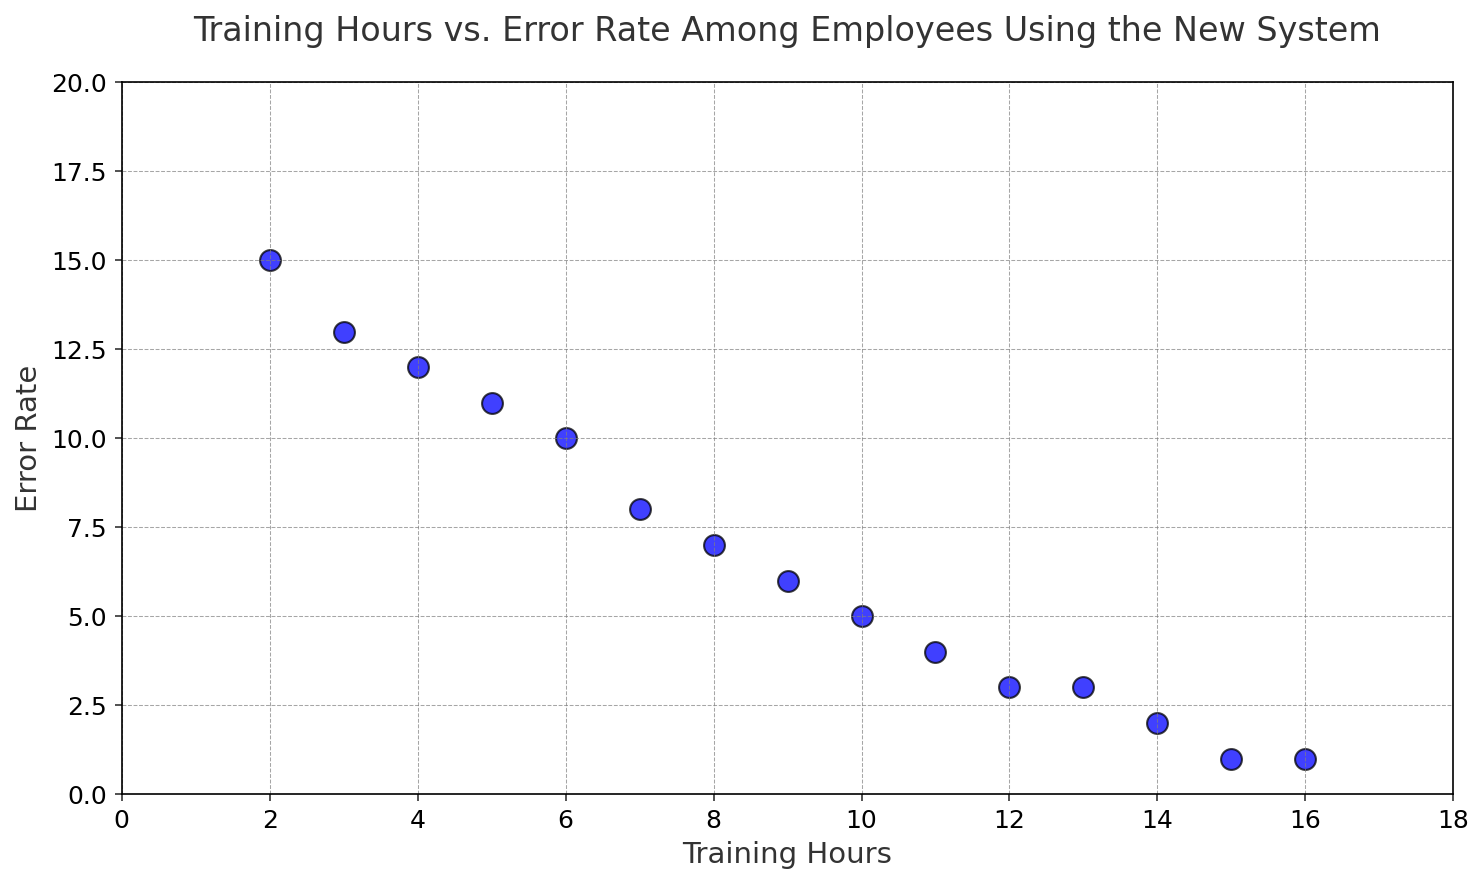How does the error rate change as training hours increase? The error rate decreases as training hours increase. This can be seen by observing the scatter plot points which show a downward trend from left to right along the 'Training Hours' axis.
Answer: It decreases What is the error rate when training hours are 10? Locate the point on the scatter plot corresponding to 10 'Training Hours'. The 'Error Rate' at this point is the y-coordinate of the point, which is 5.
Answer: 5 Compare the error rate at 4 training hours and 12 training hours. Which one is higher? Find the points for 4 and 12 training hours. At 4 training hours, the error rate is 12, and at 12 training hours, it is 3. Thus, 12 is higher than 3.
Answer: 4 training hours What is the difference in error rate between 6 and 15 training hours? Locate the points for 6 and 15 training hours. The error rate for 6 training hours is 10, and for 15 training hours is 1. Subtract 1 from 10 to get the difference, which is 9.
Answer: 9 If an employee received 8 training hours, what would be their expected error rate? Refer to the point on the scatter plot for 8 training hours. The y-coordinate here is the 'Error Rate', which is 7.
Answer: 7 Is there any point where the error rate does not decrease with more training hours? Examine the scatter plot for any points where moving to the right (more training hours) does not result in a lower error rate. Notice that from 12 to 13 training hours, the error rate remains the same at 3.
Answer: Yes How many training hours are needed to achieve an error rate lower than 5? Identify points on the scatter plot where 'Error Rate' is lower than 5. Training hours corresponding to these rates are 11 to 16.
Answer: At least 11 hours Which training hour marks the transition below an error rate of 10? Look for the first instance where the 'Error Rate' falls below 10 on the scatter plot. This happens at 7 training hours, where the error rate is 8.
Answer: 7 hours What is the total decrease in error rate from 2 to 16 training hours? Find the difference in 'Error Rate' from 2 to 16 training hours. Error rate decreases from 15 at 2 hours to 1 at 16 hours. The total decrease is 15 - 1, which equals 14.
Answer: 14 Which training hour has the highest error rate visually? Locate the highest point on the scatter plot on the 'Error Rate' axis. The highest point corresponds to the training hour of 2, with an error rate of 15.
Answer: 2 hours 